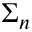Convert formula to latex. <formula><loc_0><loc_0><loc_500><loc_500>\Sigma _ { n }</formula> 